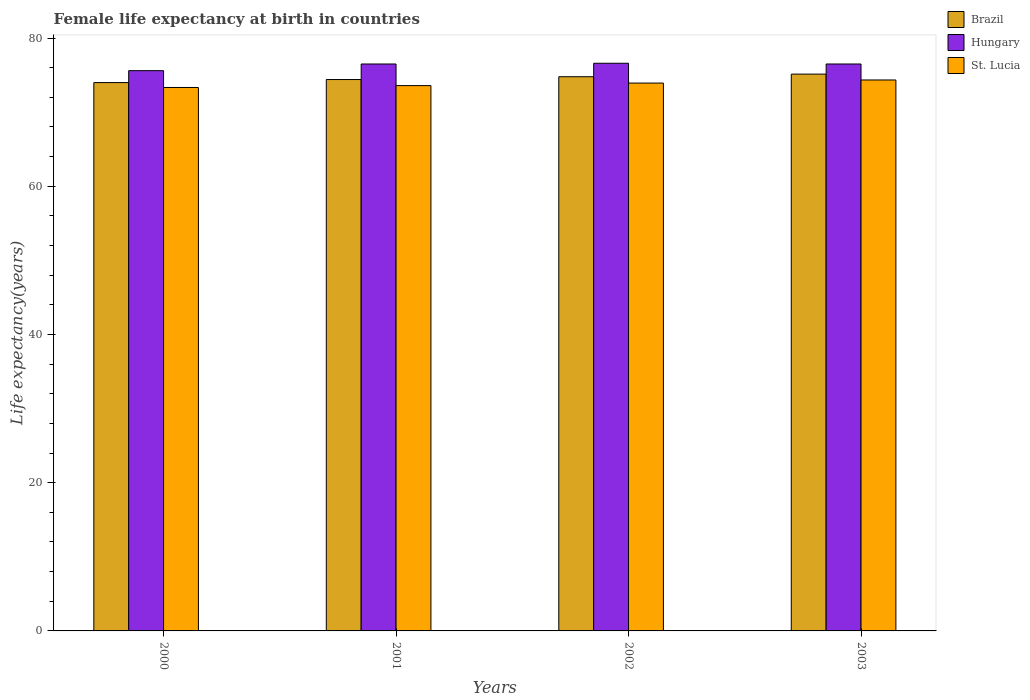Are the number of bars per tick equal to the number of legend labels?
Provide a succinct answer. Yes. How many bars are there on the 4th tick from the left?
Make the answer very short. 3. What is the label of the 3rd group of bars from the left?
Offer a terse response. 2002. In how many cases, is the number of bars for a given year not equal to the number of legend labels?
Offer a terse response. 0. What is the female life expectancy at birth in St. Lucia in 2002?
Keep it short and to the point. 73.93. Across all years, what is the maximum female life expectancy at birth in St. Lucia?
Make the answer very short. 74.34. Across all years, what is the minimum female life expectancy at birth in Brazil?
Your answer should be compact. 73.99. In which year was the female life expectancy at birth in St. Lucia maximum?
Provide a succinct answer. 2003. In which year was the female life expectancy at birth in St. Lucia minimum?
Provide a short and direct response. 2000. What is the total female life expectancy at birth in Hungary in the graph?
Give a very brief answer. 305.2. What is the difference between the female life expectancy at birth in St. Lucia in 2000 and that in 2001?
Provide a succinct answer. -0.25. What is the difference between the female life expectancy at birth in Brazil in 2000 and the female life expectancy at birth in St. Lucia in 2002?
Your answer should be very brief. 0.06. What is the average female life expectancy at birth in Hungary per year?
Give a very brief answer. 76.3. In the year 2001, what is the difference between the female life expectancy at birth in Hungary and female life expectancy at birth in St. Lucia?
Your answer should be compact. 2.92. In how many years, is the female life expectancy at birth in St. Lucia greater than 20 years?
Your answer should be compact. 4. What is the ratio of the female life expectancy at birth in Brazil in 2000 to that in 2003?
Your response must be concise. 0.98. Is the female life expectancy at birth in St. Lucia in 2000 less than that in 2003?
Give a very brief answer. Yes. Is the difference between the female life expectancy at birth in Hungary in 2000 and 2002 greater than the difference between the female life expectancy at birth in St. Lucia in 2000 and 2002?
Keep it short and to the point. No. What is the difference between the highest and the second highest female life expectancy at birth in Hungary?
Ensure brevity in your answer.  0.1. What is the difference between the highest and the lowest female life expectancy at birth in St. Lucia?
Give a very brief answer. 1.01. In how many years, is the female life expectancy at birth in Brazil greater than the average female life expectancy at birth in Brazil taken over all years?
Ensure brevity in your answer.  2. Is the sum of the female life expectancy at birth in Brazil in 2000 and 2002 greater than the maximum female life expectancy at birth in Hungary across all years?
Your response must be concise. Yes. What does the 2nd bar from the left in 2003 represents?
Your answer should be very brief. Hungary. What does the 1st bar from the right in 2002 represents?
Give a very brief answer. St. Lucia. Is it the case that in every year, the sum of the female life expectancy at birth in Brazil and female life expectancy at birth in Hungary is greater than the female life expectancy at birth in St. Lucia?
Ensure brevity in your answer.  Yes. Are all the bars in the graph horizontal?
Offer a terse response. No. What is the difference between two consecutive major ticks on the Y-axis?
Provide a succinct answer. 20. Are the values on the major ticks of Y-axis written in scientific E-notation?
Provide a short and direct response. No. Does the graph contain any zero values?
Your answer should be very brief. No. Where does the legend appear in the graph?
Provide a succinct answer. Top right. How many legend labels are there?
Keep it short and to the point. 3. What is the title of the graph?
Your answer should be very brief. Female life expectancy at birth in countries. What is the label or title of the X-axis?
Your answer should be very brief. Years. What is the label or title of the Y-axis?
Your answer should be compact. Life expectancy(years). What is the Life expectancy(years) of Brazil in 2000?
Provide a short and direct response. 73.99. What is the Life expectancy(years) of Hungary in 2000?
Your answer should be compact. 75.6. What is the Life expectancy(years) of St. Lucia in 2000?
Ensure brevity in your answer.  73.33. What is the Life expectancy(years) of Brazil in 2001?
Offer a very short reply. 74.4. What is the Life expectancy(years) in Hungary in 2001?
Your response must be concise. 76.5. What is the Life expectancy(years) of St. Lucia in 2001?
Provide a short and direct response. 73.58. What is the Life expectancy(years) in Brazil in 2002?
Give a very brief answer. 74.78. What is the Life expectancy(years) in Hungary in 2002?
Your response must be concise. 76.6. What is the Life expectancy(years) of St. Lucia in 2002?
Your answer should be very brief. 73.93. What is the Life expectancy(years) in Brazil in 2003?
Provide a short and direct response. 75.13. What is the Life expectancy(years) in Hungary in 2003?
Keep it short and to the point. 76.5. What is the Life expectancy(years) of St. Lucia in 2003?
Your answer should be compact. 74.34. Across all years, what is the maximum Life expectancy(years) of Brazil?
Make the answer very short. 75.13. Across all years, what is the maximum Life expectancy(years) of Hungary?
Offer a terse response. 76.6. Across all years, what is the maximum Life expectancy(years) in St. Lucia?
Offer a very short reply. 74.34. Across all years, what is the minimum Life expectancy(years) in Brazil?
Ensure brevity in your answer.  73.99. Across all years, what is the minimum Life expectancy(years) of Hungary?
Provide a succinct answer. 75.6. Across all years, what is the minimum Life expectancy(years) of St. Lucia?
Ensure brevity in your answer.  73.33. What is the total Life expectancy(years) in Brazil in the graph?
Provide a succinct answer. 298.31. What is the total Life expectancy(years) of Hungary in the graph?
Your answer should be compact. 305.2. What is the total Life expectancy(years) of St. Lucia in the graph?
Provide a succinct answer. 295.19. What is the difference between the Life expectancy(years) in Brazil in 2000 and that in 2001?
Make the answer very short. -0.41. What is the difference between the Life expectancy(years) in St. Lucia in 2000 and that in 2001?
Your answer should be compact. -0.25. What is the difference between the Life expectancy(years) in Brazil in 2000 and that in 2002?
Keep it short and to the point. -0.79. What is the difference between the Life expectancy(years) in Hungary in 2000 and that in 2002?
Offer a terse response. -1. What is the difference between the Life expectancy(years) of St. Lucia in 2000 and that in 2002?
Make the answer very short. -0.59. What is the difference between the Life expectancy(years) of Brazil in 2000 and that in 2003?
Your answer should be compact. -1.14. What is the difference between the Life expectancy(years) of Hungary in 2000 and that in 2003?
Your answer should be compact. -0.9. What is the difference between the Life expectancy(years) of St. Lucia in 2000 and that in 2003?
Offer a terse response. -1.01. What is the difference between the Life expectancy(years) in Brazil in 2001 and that in 2002?
Offer a very short reply. -0.38. What is the difference between the Life expectancy(years) of St. Lucia in 2001 and that in 2002?
Give a very brief answer. -0.34. What is the difference between the Life expectancy(years) in Brazil in 2001 and that in 2003?
Keep it short and to the point. -0.73. What is the difference between the Life expectancy(years) in St. Lucia in 2001 and that in 2003?
Provide a succinct answer. -0.76. What is the difference between the Life expectancy(years) of Brazil in 2002 and that in 2003?
Your response must be concise. -0.35. What is the difference between the Life expectancy(years) of St. Lucia in 2002 and that in 2003?
Your response must be concise. -0.42. What is the difference between the Life expectancy(years) of Brazil in 2000 and the Life expectancy(years) of Hungary in 2001?
Ensure brevity in your answer.  -2.51. What is the difference between the Life expectancy(years) of Brazil in 2000 and the Life expectancy(years) of St. Lucia in 2001?
Give a very brief answer. 0.41. What is the difference between the Life expectancy(years) in Hungary in 2000 and the Life expectancy(years) in St. Lucia in 2001?
Keep it short and to the point. 2.02. What is the difference between the Life expectancy(years) of Brazil in 2000 and the Life expectancy(years) of Hungary in 2002?
Give a very brief answer. -2.61. What is the difference between the Life expectancy(years) in Brazil in 2000 and the Life expectancy(years) in St. Lucia in 2002?
Provide a succinct answer. 0.07. What is the difference between the Life expectancy(years) in Hungary in 2000 and the Life expectancy(years) in St. Lucia in 2002?
Your answer should be compact. 1.67. What is the difference between the Life expectancy(years) of Brazil in 2000 and the Life expectancy(years) of Hungary in 2003?
Ensure brevity in your answer.  -2.51. What is the difference between the Life expectancy(years) of Brazil in 2000 and the Life expectancy(years) of St. Lucia in 2003?
Make the answer very short. -0.35. What is the difference between the Life expectancy(years) in Hungary in 2000 and the Life expectancy(years) in St. Lucia in 2003?
Offer a terse response. 1.25. What is the difference between the Life expectancy(years) in Brazil in 2001 and the Life expectancy(years) in Hungary in 2002?
Your response must be concise. -2.2. What is the difference between the Life expectancy(years) of Brazil in 2001 and the Life expectancy(years) of St. Lucia in 2002?
Provide a short and direct response. 0.48. What is the difference between the Life expectancy(years) in Hungary in 2001 and the Life expectancy(years) in St. Lucia in 2002?
Offer a very short reply. 2.57. What is the difference between the Life expectancy(years) in Brazil in 2001 and the Life expectancy(years) in Hungary in 2003?
Your answer should be compact. -2.1. What is the difference between the Life expectancy(years) of Brazil in 2001 and the Life expectancy(years) of St. Lucia in 2003?
Provide a short and direct response. 0.06. What is the difference between the Life expectancy(years) of Hungary in 2001 and the Life expectancy(years) of St. Lucia in 2003?
Your response must be concise. 2.15. What is the difference between the Life expectancy(years) in Brazil in 2002 and the Life expectancy(years) in Hungary in 2003?
Provide a succinct answer. -1.72. What is the difference between the Life expectancy(years) of Brazil in 2002 and the Life expectancy(years) of St. Lucia in 2003?
Provide a succinct answer. 0.44. What is the difference between the Life expectancy(years) of Hungary in 2002 and the Life expectancy(years) of St. Lucia in 2003?
Your answer should be very brief. 2.25. What is the average Life expectancy(years) of Brazil per year?
Give a very brief answer. 74.58. What is the average Life expectancy(years) in Hungary per year?
Keep it short and to the point. 76.3. What is the average Life expectancy(years) of St. Lucia per year?
Keep it short and to the point. 73.8. In the year 2000, what is the difference between the Life expectancy(years) in Brazil and Life expectancy(years) in Hungary?
Give a very brief answer. -1.61. In the year 2000, what is the difference between the Life expectancy(years) of Brazil and Life expectancy(years) of St. Lucia?
Make the answer very short. 0.66. In the year 2000, what is the difference between the Life expectancy(years) of Hungary and Life expectancy(years) of St. Lucia?
Provide a succinct answer. 2.27. In the year 2001, what is the difference between the Life expectancy(years) of Brazil and Life expectancy(years) of Hungary?
Give a very brief answer. -2.1. In the year 2001, what is the difference between the Life expectancy(years) in Brazil and Life expectancy(years) in St. Lucia?
Your answer should be compact. 0.82. In the year 2001, what is the difference between the Life expectancy(years) of Hungary and Life expectancy(years) of St. Lucia?
Provide a succinct answer. 2.92. In the year 2002, what is the difference between the Life expectancy(years) in Brazil and Life expectancy(years) in Hungary?
Your answer should be very brief. -1.82. In the year 2002, what is the difference between the Life expectancy(years) of Brazil and Life expectancy(years) of St. Lucia?
Ensure brevity in your answer.  0.86. In the year 2002, what is the difference between the Life expectancy(years) of Hungary and Life expectancy(years) of St. Lucia?
Provide a short and direct response. 2.67. In the year 2003, what is the difference between the Life expectancy(years) of Brazil and Life expectancy(years) of Hungary?
Give a very brief answer. -1.37. In the year 2003, what is the difference between the Life expectancy(years) in Brazil and Life expectancy(years) in St. Lucia?
Provide a succinct answer. 0.79. In the year 2003, what is the difference between the Life expectancy(years) in Hungary and Life expectancy(years) in St. Lucia?
Your response must be concise. 2.15. What is the ratio of the Life expectancy(years) in Hungary in 2000 to that in 2001?
Make the answer very short. 0.99. What is the ratio of the Life expectancy(years) of St. Lucia in 2000 to that in 2001?
Give a very brief answer. 1. What is the ratio of the Life expectancy(years) in Hungary in 2000 to that in 2002?
Keep it short and to the point. 0.99. What is the ratio of the Life expectancy(years) in St. Lucia in 2000 to that in 2002?
Make the answer very short. 0.99. What is the ratio of the Life expectancy(years) in Brazil in 2000 to that in 2003?
Offer a very short reply. 0.98. What is the ratio of the Life expectancy(years) in Hungary in 2000 to that in 2003?
Give a very brief answer. 0.99. What is the ratio of the Life expectancy(years) of St. Lucia in 2000 to that in 2003?
Ensure brevity in your answer.  0.99. What is the ratio of the Life expectancy(years) of St. Lucia in 2001 to that in 2002?
Keep it short and to the point. 1. What is the ratio of the Life expectancy(years) of Brazil in 2001 to that in 2003?
Offer a terse response. 0.99. What is the ratio of the Life expectancy(years) in St. Lucia in 2001 to that in 2003?
Your answer should be compact. 0.99. What is the ratio of the Life expectancy(years) of Brazil in 2002 to that in 2003?
Keep it short and to the point. 1. What is the difference between the highest and the second highest Life expectancy(years) in Brazil?
Offer a terse response. 0.35. What is the difference between the highest and the second highest Life expectancy(years) of Hungary?
Make the answer very short. 0.1. What is the difference between the highest and the second highest Life expectancy(years) in St. Lucia?
Your response must be concise. 0.42. What is the difference between the highest and the lowest Life expectancy(years) in Brazil?
Provide a succinct answer. 1.14. 